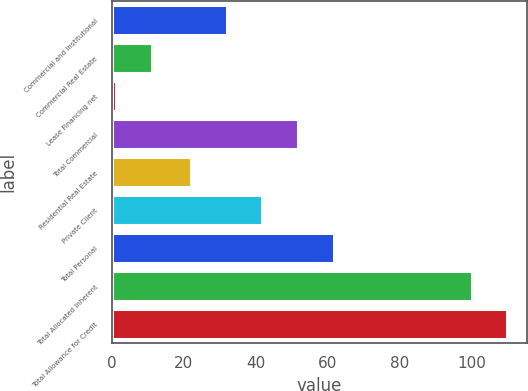Convert chart to OTSL. <chart><loc_0><loc_0><loc_500><loc_500><bar_chart><fcel>Commercial and Institutional<fcel>Commercial Real Estate<fcel>Lease Financing net<fcel>Total Commercial<fcel>Residential Real Estate<fcel>Private Client<fcel>Total Personal<fcel>Total Allocated Inherent<fcel>Total Allowance for Credit<nl><fcel>31.9<fcel>11<fcel>1<fcel>51.7<fcel>22<fcel>41.8<fcel>61.6<fcel>100<fcel>109.9<nl></chart> 